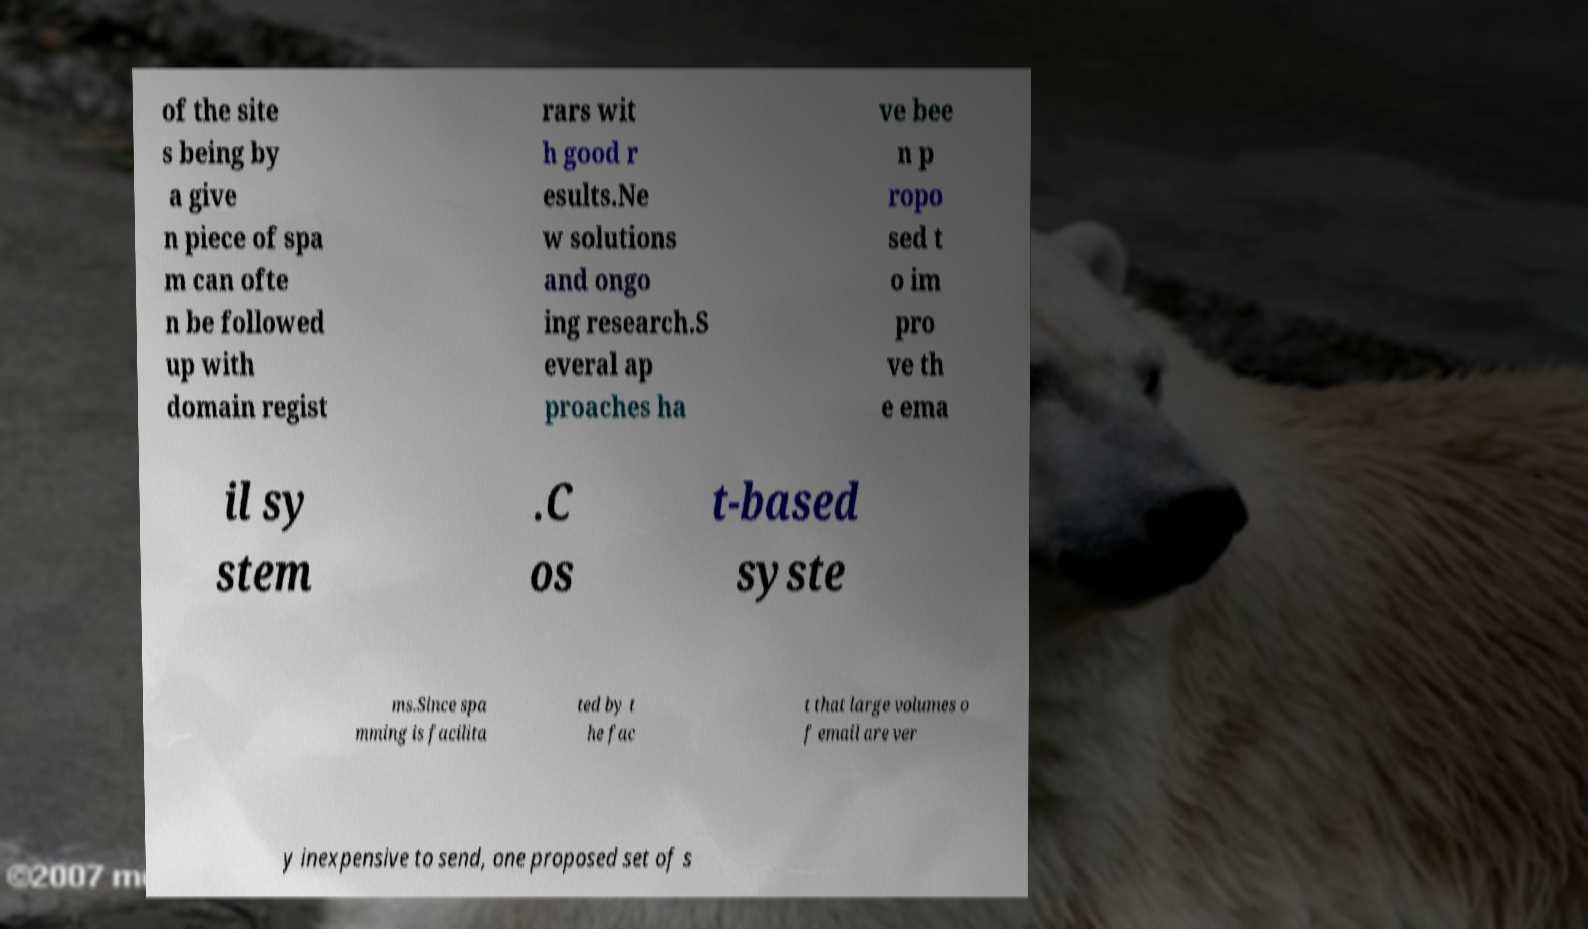Could you extract and type out the text from this image? of the site s being by a give n piece of spa m can ofte n be followed up with domain regist rars wit h good r esults.Ne w solutions and ongo ing research.S everal ap proaches ha ve bee n p ropo sed t o im pro ve th e ema il sy stem .C os t-based syste ms.Since spa mming is facilita ted by t he fac t that large volumes o f email are ver y inexpensive to send, one proposed set of s 